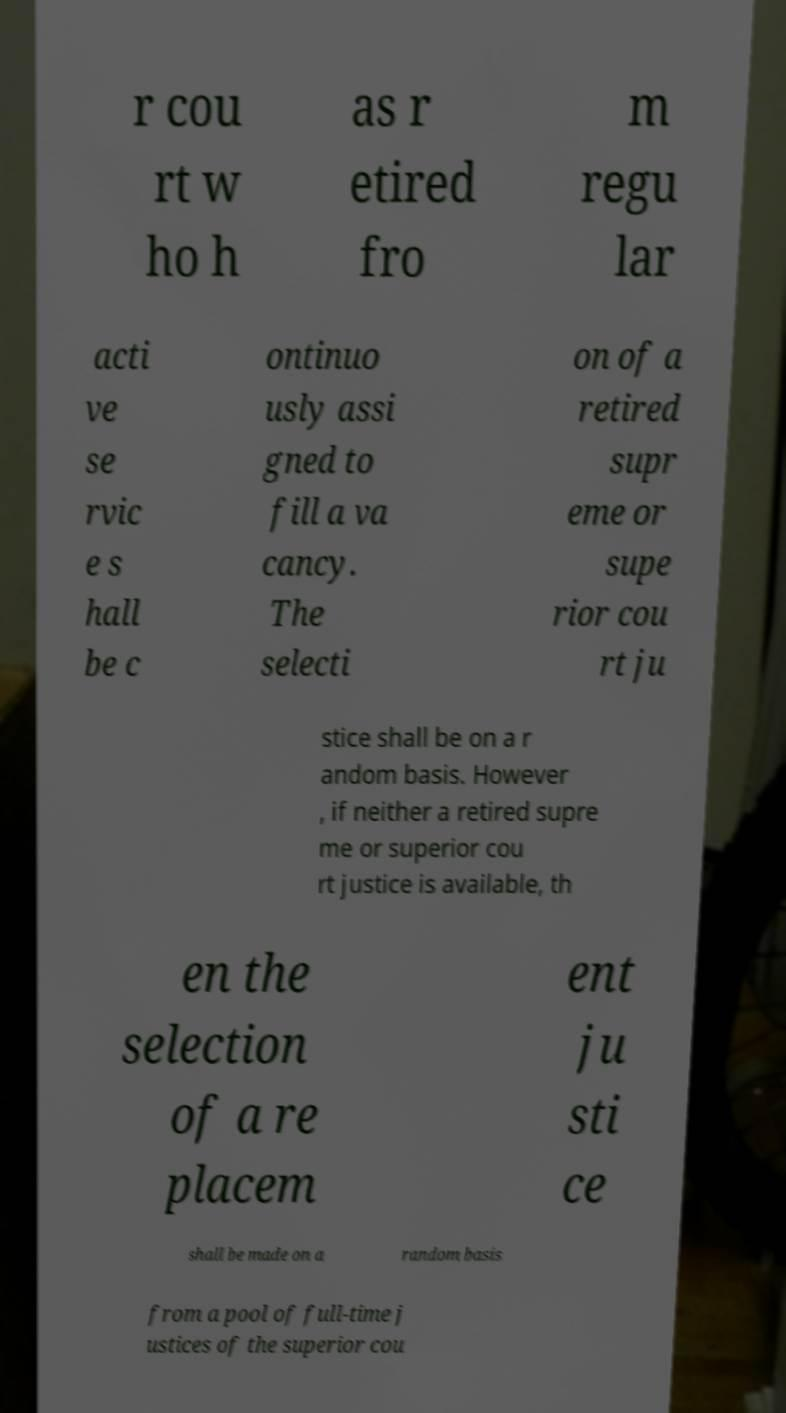There's text embedded in this image that I need extracted. Can you transcribe it verbatim? r cou rt w ho h as r etired fro m regu lar acti ve se rvic e s hall be c ontinuo usly assi gned to fill a va cancy. The selecti on of a retired supr eme or supe rior cou rt ju stice shall be on a r andom basis. However , if neither a retired supre me or superior cou rt justice is available, th en the selection of a re placem ent ju sti ce shall be made on a random basis from a pool of full-time j ustices of the superior cou 